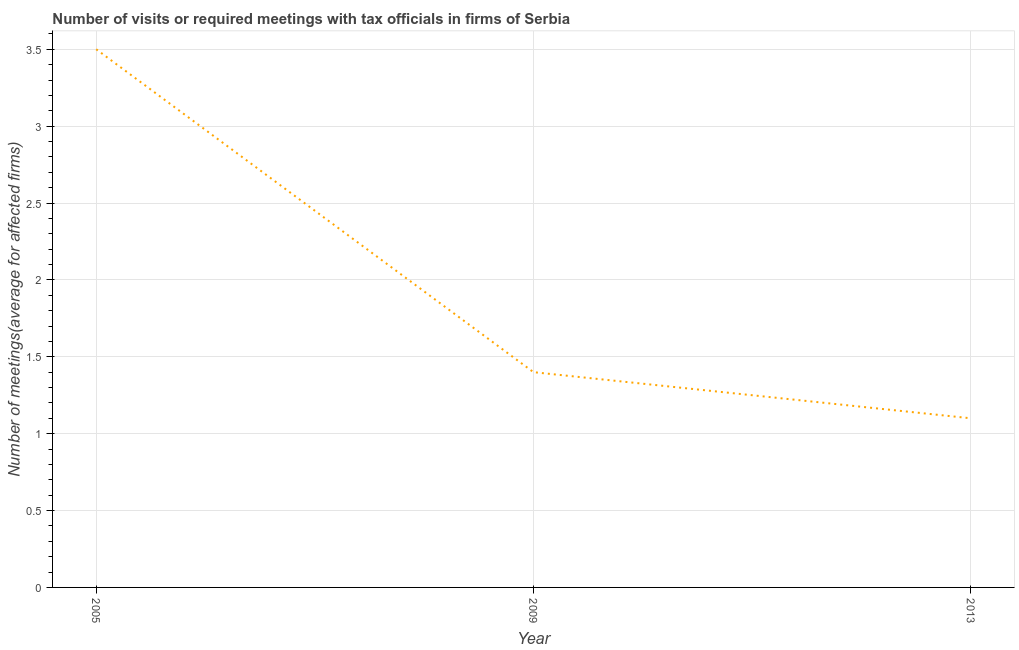In which year was the number of required meetings with tax officials maximum?
Offer a very short reply. 2005. What is the difference between the number of required meetings with tax officials in 2005 and 2009?
Provide a short and direct response. 2.1. What is the median number of required meetings with tax officials?
Make the answer very short. 1.4. In how many years, is the number of required meetings with tax officials greater than 2.9 ?
Provide a short and direct response. 1. Do a majority of the years between 2013 and 2005 (inclusive) have number of required meetings with tax officials greater than 1.9 ?
Your answer should be compact. No. What is the ratio of the number of required meetings with tax officials in 2009 to that in 2013?
Ensure brevity in your answer.  1.27. Is the sum of the number of required meetings with tax officials in 2005 and 2009 greater than the maximum number of required meetings with tax officials across all years?
Provide a succinct answer. Yes. What is the difference between the highest and the lowest number of required meetings with tax officials?
Offer a terse response. 2.4. In how many years, is the number of required meetings with tax officials greater than the average number of required meetings with tax officials taken over all years?
Provide a succinct answer. 1. Does the number of required meetings with tax officials monotonically increase over the years?
Ensure brevity in your answer.  No. How many lines are there?
Offer a very short reply. 1. How many years are there in the graph?
Provide a succinct answer. 3. Does the graph contain any zero values?
Make the answer very short. No. Does the graph contain grids?
Provide a short and direct response. Yes. What is the title of the graph?
Your answer should be very brief. Number of visits or required meetings with tax officials in firms of Serbia. What is the label or title of the Y-axis?
Keep it short and to the point. Number of meetings(average for affected firms). What is the Number of meetings(average for affected firms) of 2005?
Offer a very short reply. 3.5. What is the Number of meetings(average for affected firms) of 2009?
Give a very brief answer. 1.4. What is the Number of meetings(average for affected firms) in 2013?
Ensure brevity in your answer.  1.1. What is the difference between the Number of meetings(average for affected firms) in 2005 and 2009?
Your response must be concise. 2.1. What is the difference between the Number of meetings(average for affected firms) in 2005 and 2013?
Your answer should be compact. 2.4. What is the difference between the Number of meetings(average for affected firms) in 2009 and 2013?
Provide a short and direct response. 0.3. What is the ratio of the Number of meetings(average for affected firms) in 2005 to that in 2013?
Keep it short and to the point. 3.18. What is the ratio of the Number of meetings(average for affected firms) in 2009 to that in 2013?
Provide a succinct answer. 1.27. 